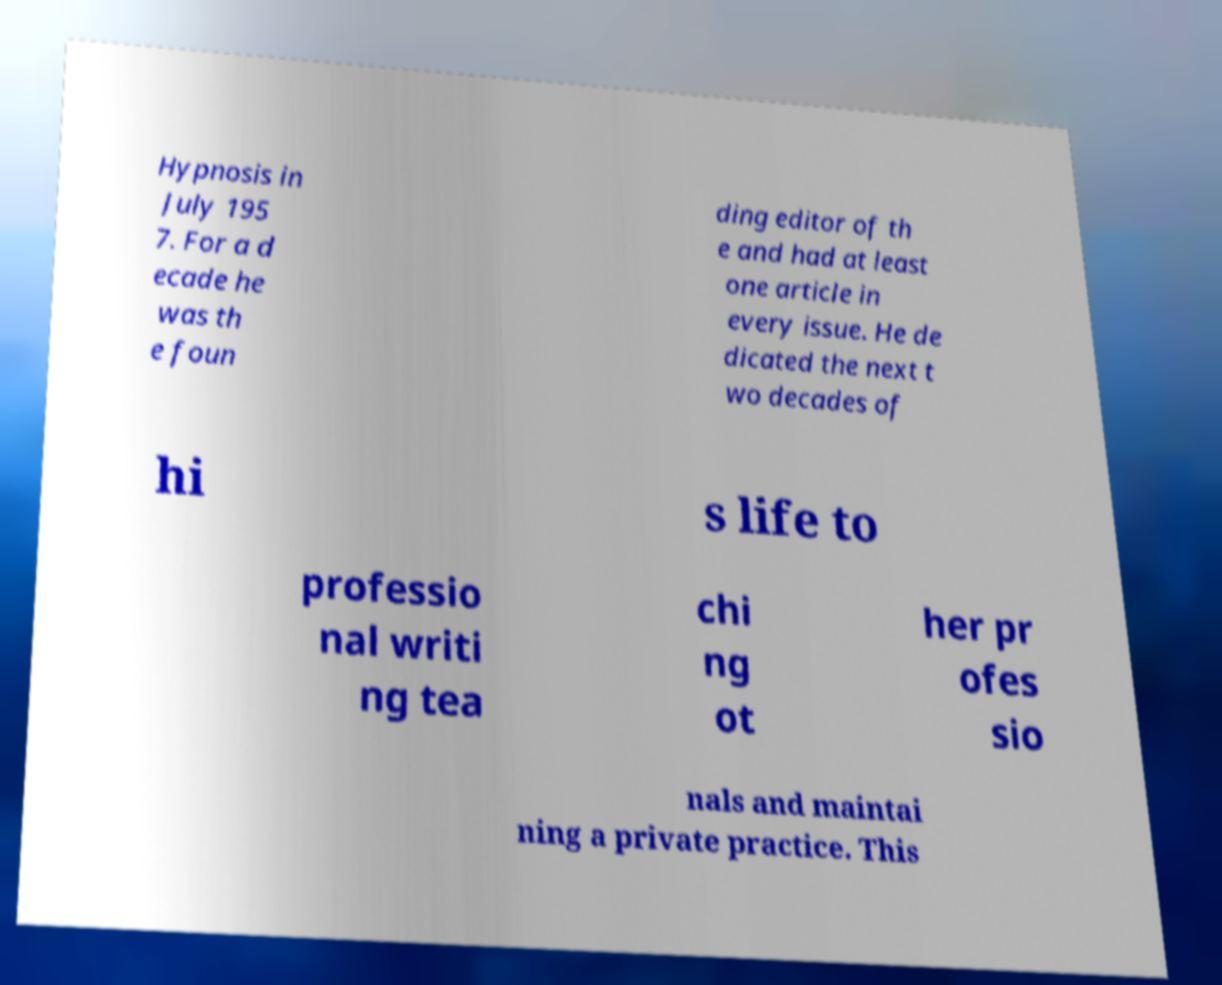Could you assist in decoding the text presented in this image and type it out clearly? Hypnosis in July 195 7. For a d ecade he was th e foun ding editor of th e and had at least one article in every issue. He de dicated the next t wo decades of hi s life to professio nal writi ng tea chi ng ot her pr ofes sio nals and maintai ning a private practice. This 